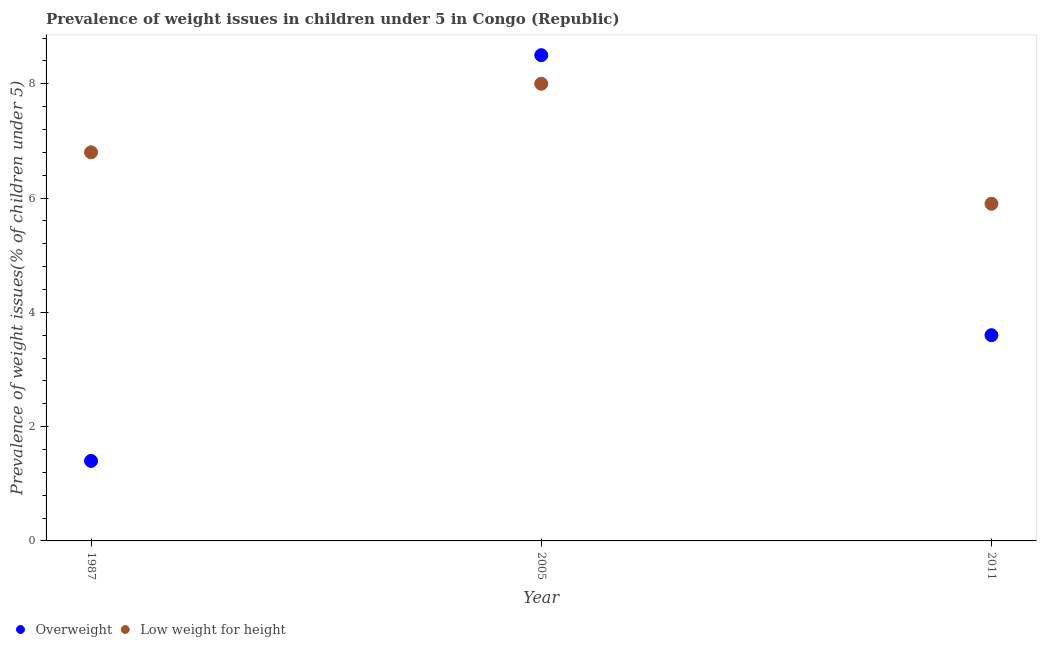How many different coloured dotlines are there?
Offer a very short reply. 2. What is the percentage of overweight children in 1987?
Offer a terse response. 1.4. Across all years, what is the minimum percentage of overweight children?
Your response must be concise. 1.4. In which year was the percentage of overweight children maximum?
Offer a very short reply. 2005. What is the total percentage of overweight children in the graph?
Give a very brief answer. 13.5. What is the difference between the percentage of underweight children in 1987 and that in 2011?
Give a very brief answer. 0.9. What is the difference between the percentage of underweight children in 1987 and the percentage of overweight children in 2005?
Your response must be concise. -1.7. What is the average percentage of overweight children per year?
Make the answer very short. 4.5. In the year 2011, what is the difference between the percentage of overweight children and percentage of underweight children?
Keep it short and to the point. -2.3. What is the ratio of the percentage of underweight children in 2005 to that in 2011?
Your answer should be compact. 1.36. Is the percentage of overweight children in 1987 less than that in 2005?
Ensure brevity in your answer.  Yes. What is the difference between the highest and the second highest percentage of underweight children?
Keep it short and to the point. 1.2. What is the difference between the highest and the lowest percentage of overweight children?
Give a very brief answer. 7.1. Does the percentage of overweight children monotonically increase over the years?
Your response must be concise. No. How many dotlines are there?
Your answer should be very brief. 2. Does the graph contain any zero values?
Your response must be concise. No. Where does the legend appear in the graph?
Offer a terse response. Bottom left. How many legend labels are there?
Your answer should be very brief. 2. How are the legend labels stacked?
Your answer should be compact. Horizontal. What is the title of the graph?
Provide a short and direct response. Prevalence of weight issues in children under 5 in Congo (Republic). What is the label or title of the Y-axis?
Your answer should be compact. Prevalence of weight issues(% of children under 5). What is the Prevalence of weight issues(% of children under 5) of Overweight in 1987?
Provide a succinct answer. 1.4. What is the Prevalence of weight issues(% of children under 5) of Low weight for height in 1987?
Offer a very short reply. 6.8. What is the Prevalence of weight issues(% of children under 5) of Overweight in 2005?
Your response must be concise. 8.5. What is the Prevalence of weight issues(% of children under 5) of Low weight for height in 2005?
Your answer should be very brief. 8. What is the Prevalence of weight issues(% of children under 5) of Overweight in 2011?
Your response must be concise. 3.6. What is the Prevalence of weight issues(% of children under 5) of Low weight for height in 2011?
Give a very brief answer. 5.9. Across all years, what is the maximum Prevalence of weight issues(% of children under 5) of Overweight?
Ensure brevity in your answer.  8.5. Across all years, what is the maximum Prevalence of weight issues(% of children under 5) in Low weight for height?
Make the answer very short. 8. Across all years, what is the minimum Prevalence of weight issues(% of children under 5) in Overweight?
Provide a succinct answer. 1.4. Across all years, what is the minimum Prevalence of weight issues(% of children under 5) of Low weight for height?
Your response must be concise. 5.9. What is the total Prevalence of weight issues(% of children under 5) of Low weight for height in the graph?
Provide a short and direct response. 20.7. What is the difference between the Prevalence of weight issues(% of children under 5) in Overweight in 1987 and that in 2005?
Offer a terse response. -7.1. What is the difference between the Prevalence of weight issues(% of children under 5) of Low weight for height in 1987 and that in 2005?
Your response must be concise. -1.2. What is the difference between the Prevalence of weight issues(% of children under 5) in Low weight for height in 1987 and that in 2011?
Offer a very short reply. 0.9. What is the difference between the Prevalence of weight issues(% of children under 5) in Overweight in 2005 and that in 2011?
Keep it short and to the point. 4.9. What is the difference between the Prevalence of weight issues(% of children under 5) in Low weight for height in 2005 and that in 2011?
Your response must be concise. 2.1. What is the difference between the Prevalence of weight issues(% of children under 5) in Overweight in 1987 and the Prevalence of weight issues(% of children under 5) in Low weight for height in 2011?
Keep it short and to the point. -4.5. In the year 1987, what is the difference between the Prevalence of weight issues(% of children under 5) of Overweight and Prevalence of weight issues(% of children under 5) of Low weight for height?
Provide a succinct answer. -5.4. In the year 2011, what is the difference between the Prevalence of weight issues(% of children under 5) in Overweight and Prevalence of weight issues(% of children under 5) in Low weight for height?
Your response must be concise. -2.3. What is the ratio of the Prevalence of weight issues(% of children under 5) in Overweight in 1987 to that in 2005?
Provide a short and direct response. 0.16. What is the ratio of the Prevalence of weight issues(% of children under 5) of Overweight in 1987 to that in 2011?
Your response must be concise. 0.39. What is the ratio of the Prevalence of weight issues(% of children under 5) of Low weight for height in 1987 to that in 2011?
Provide a succinct answer. 1.15. What is the ratio of the Prevalence of weight issues(% of children under 5) of Overweight in 2005 to that in 2011?
Your answer should be compact. 2.36. What is the ratio of the Prevalence of weight issues(% of children under 5) in Low weight for height in 2005 to that in 2011?
Your answer should be compact. 1.36. What is the difference between the highest and the second highest Prevalence of weight issues(% of children under 5) of Low weight for height?
Your answer should be very brief. 1.2. 